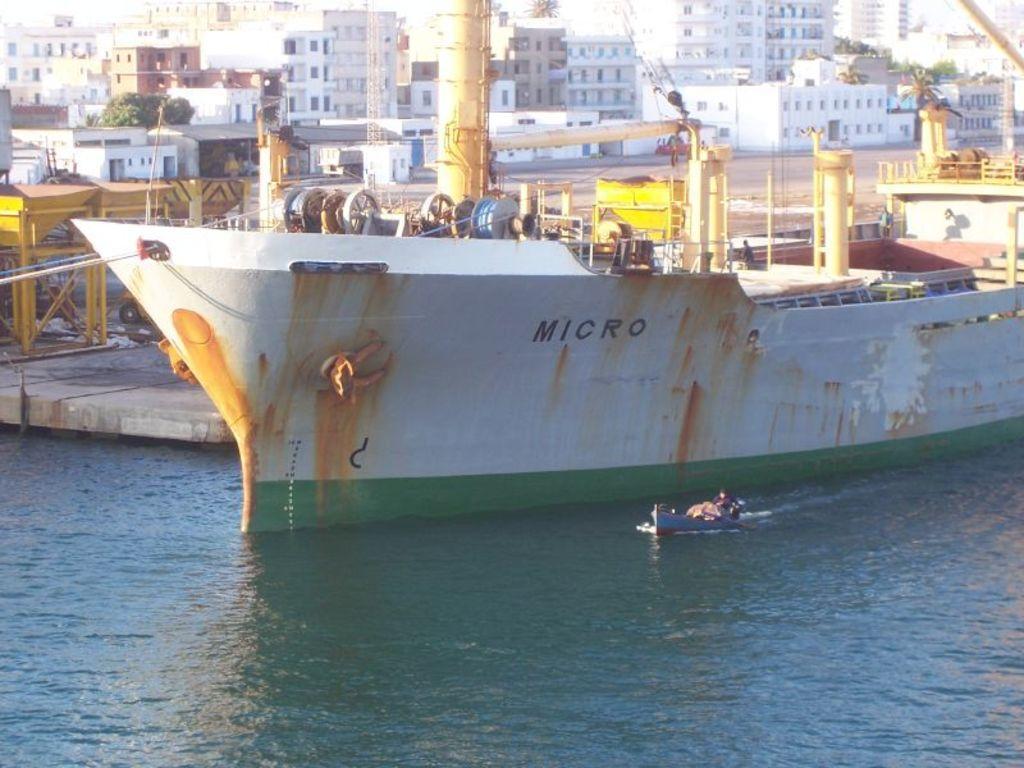Please provide a concise description of this image. In this image, we can see boats on the water and in the background, there are buildings, trees and poles. 